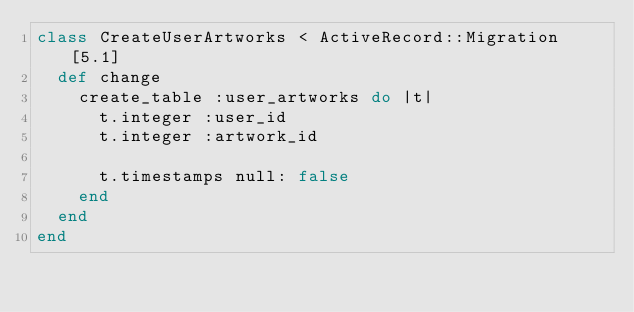Convert code to text. <code><loc_0><loc_0><loc_500><loc_500><_Ruby_>class CreateUserArtworks < ActiveRecord::Migration[5.1]
  def change
    create_table :user_artworks do |t|
      t.integer :user_id
      t.integer :artwork_id

      t.timestamps null: false
    end
  end
end
</code> 